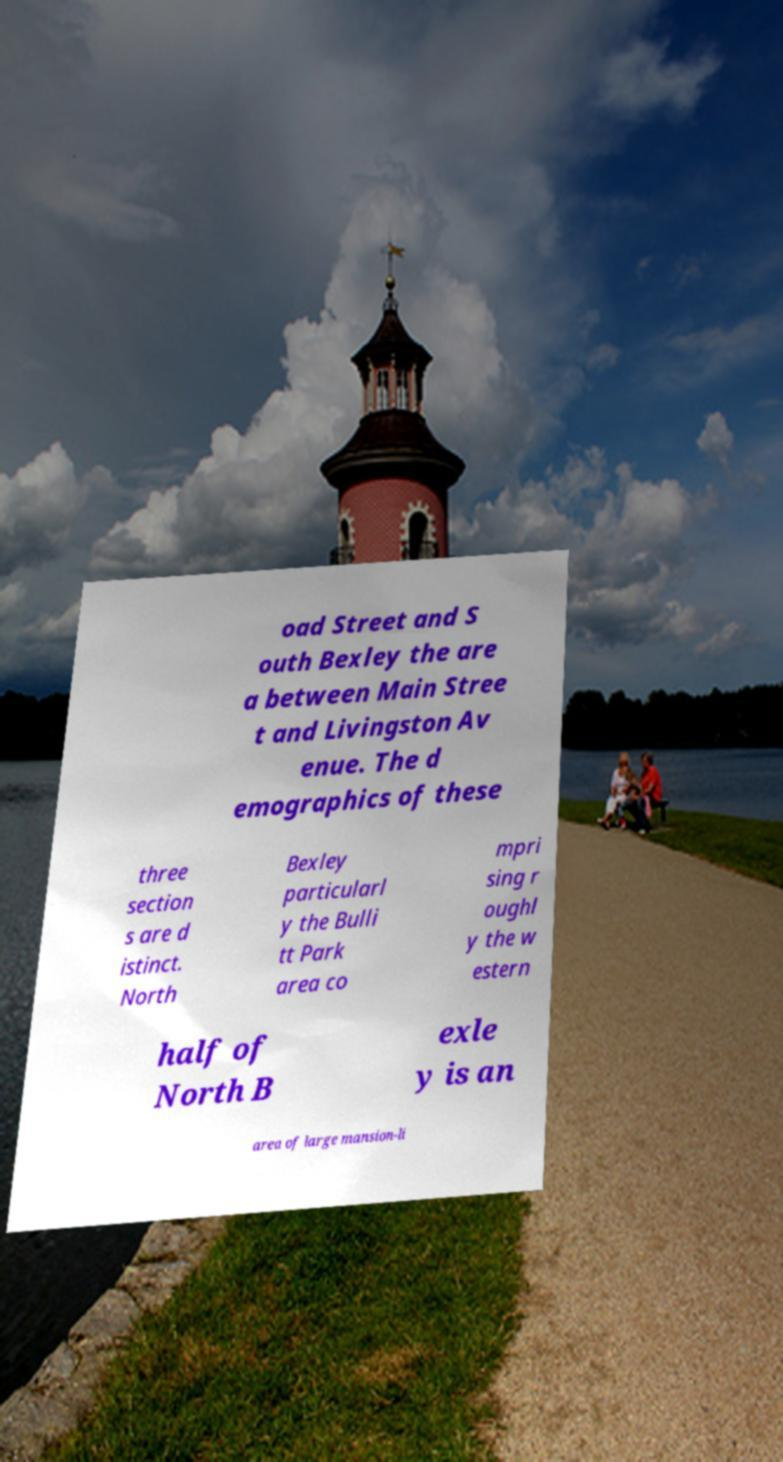Please identify and transcribe the text found in this image. oad Street and S outh Bexley the are a between Main Stree t and Livingston Av enue. The d emographics of these three section s are d istinct. North Bexley particularl y the Bulli tt Park area co mpri sing r oughl y the w estern half of North B exle y is an area of large mansion-li 